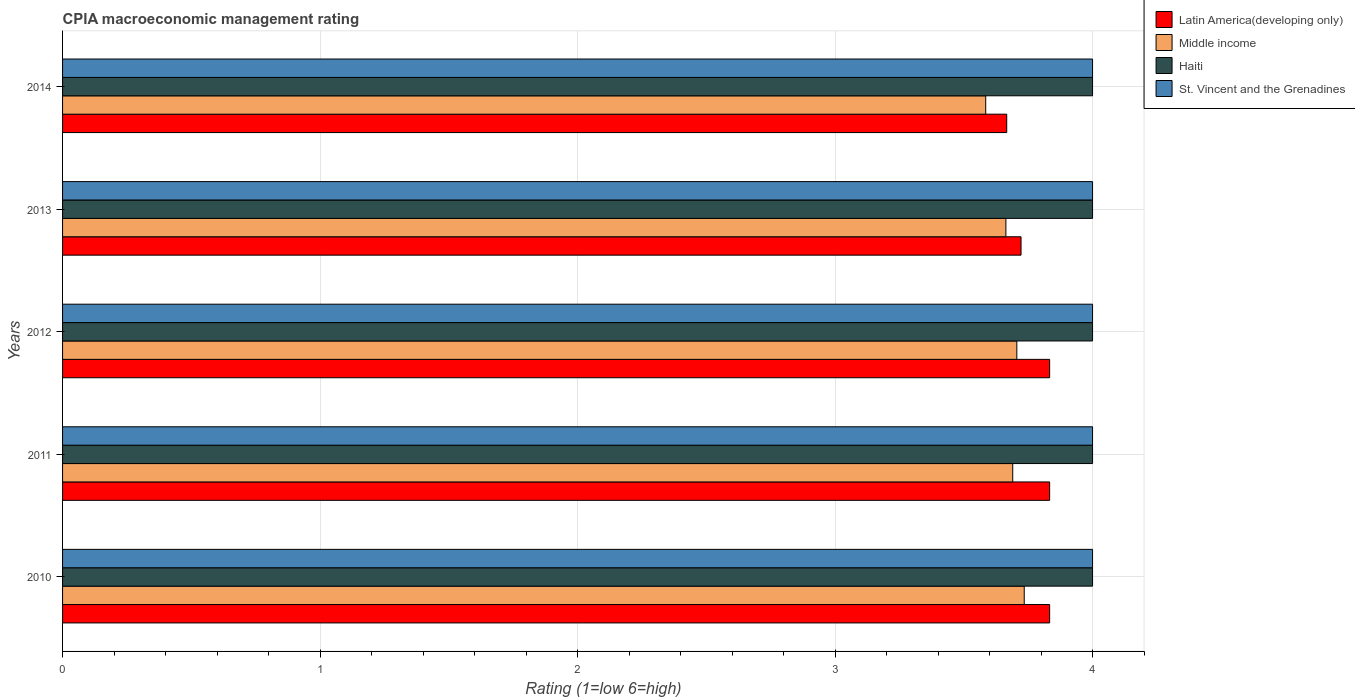How many bars are there on the 3rd tick from the top?
Provide a short and direct response. 4. What is the CPIA rating in Haiti in 2012?
Ensure brevity in your answer.  4. Across all years, what is the maximum CPIA rating in Latin America(developing only)?
Your response must be concise. 3.83. Across all years, what is the minimum CPIA rating in St. Vincent and the Grenadines?
Provide a succinct answer. 4. In which year was the CPIA rating in Latin America(developing only) maximum?
Your answer should be compact. 2010. In which year was the CPIA rating in Haiti minimum?
Offer a terse response. 2010. What is the total CPIA rating in Latin America(developing only) in the graph?
Ensure brevity in your answer.  18.89. What is the difference between the CPIA rating in Latin America(developing only) in 2011 and that in 2013?
Ensure brevity in your answer.  0.11. What is the difference between the CPIA rating in St. Vincent and the Grenadines in 2013 and the CPIA rating in Middle income in 2012?
Offer a very short reply. 0.29. What is the average CPIA rating in Middle income per year?
Ensure brevity in your answer.  3.68. In the year 2010, what is the difference between the CPIA rating in St. Vincent and the Grenadines and CPIA rating in Latin America(developing only)?
Give a very brief answer. 0.17. What is the ratio of the CPIA rating in Middle income in 2012 to that in 2014?
Provide a succinct answer. 1.03. Is the CPIA rating in Latin America(developing only) in 2012 less than that in 2014?
Your answer should be very brief. No. Is the difference between the CPIA rating in St. Vincent and the Grenadines in 2010 and 2014 greater than the difference between the CPIA rating in Latin America(developing only) in 2010 and 2014?
Your answer should be very brief. No. What is the difference between the highest and the second highest CPIA rating in St. Vincent and the Grenadines?
Make the answer very short. 0. In how many years, is the CPIA rating in Middle income greater than the average CPIA rating in Middle income taken over all years?
Provide a succinct answer. 3. Is it the case that in every year, the sum of the CPIA rating in Middle income and CPIA rating in St. Vincent and the Grenadines is greater than the sum of CPIA rating in Latin America(developing only) and CPIA rating in Haiti?
Your answer should be very brief. Yes. What does the 1st bar from the top in 2012 represents?
Give a very brief answer. St. Vincent and the Grenadines. What does the 1st bar from the bottom in 2011 represents?
Keep it short and to the point. Latin America(developing only). What is the difference between two consecutive major ticks on the X-axis?
Your response must be concise. 1. Are the values on the major ticks of X-axis written in scientific E-notation?
Offer a very short reply. No. How many legend labels are there?
Offer a terse response. 4. What is the title of the graph?
Your answer should be compact. CPIA macroeconomic management rating. Does "Malawi" appear as one of the legend labels in the graph?
Offer a terse response. No. What is the label or title of the X-axis?
Offer a terse response. Rating (1=low 6=high). What is the Rating (1=low 6=high) of Latin America(developing only) in 2010?
Your response must be concise. 3.83. What is the Rating (1=low 6=high) in Middle income in 2010?
Ensure brevity in your answer.  3.73. What is the Rating (1=low 6=high) in Haiti in 2010?
Provide a short and direct response. 4. What is the Rating (1=low 6=high) of Latin America(developing only) in 2011?
Offer a terse response. 3.83. What is the Rating (1=low 6=high) in Middle income in 2011?
Your answer should be compact. 3.69. What is the Rating (1=low 6=high) of Haiti in 2011?
Keep it short and to the point. 4. What is the Rating (1=low 6=high) in Latin America(developing only) in 2012?
Give a very brief answer. 3.83. What is the Rating (1=low 6=high) of Middle income in 2012?
Keep it short and to the point. 3.71. What is the Rating (1=low 6=high) of Haiti in 2012?
Keep it short and to the point. 4. What is the Rating (1=low 6=high) of Latin America(developing only) in 2013?
Provide a short and direct response. 3.72. What is the Rating (1=low 6=high) in Middle income in 2013?
Keep it short and to the point. 3.66. What is the Rating (1=low 6=high) of St. Vincent and the Grenadines in 2013?
Provide a succinct answer. 4. What is the Rating (1=low 6=high) of Latin America(developing only) in 2014?
Give a very brief answer. 3.67. What is the Rating (1=low 6=high) of Middle income in 2014?
Your response must be concise. 3.59. What is the Rating (1=low 6=high) of Haiti in 2014?
Your answer should be compact. 4. What is the Rating (1=low 6=high) of St. Vincent and the Grenadines in 2014?
Offer a terse response. 4. Across all years, what is the maximum Rating (1=low 6=high) in Latin America(developing only)?
Provide a short and direct response. 3.83. Across all years, what is the maximum Rating (1=low 6=high) in Middle income?
Provide a succinct answer. 3.73. Across all years, what is the maximum Rating (1=low 6=high) in Haiti?
Give a very brief answer. 4. Across all years, what is the maximum Rating (1=low 6=high) of St. Vincent and the Grenadines?
Your response must be concise. 4. Across all years, what is the minimum Rating (1=low 6=high) of Latin America(developing only)?
Make the answer very short. 3.67. Across all years, what is the minimum Rating (1=low 6=high) in Middle income?
Make the answer very short. 3.59. Across all years, what is the minimum Rating (1=low 6=high) in St. Vincent and the Grenadines?
Ensure brevity in your answer.  4. What is the total Rating (1=low 6=high) of Latin America(developing only) in the graph?
Give a very brief answer. 18.89. What is the total Rating (1=low 6=high) of Middle income in the graph?
Your answer should be compact. 18.38. What is the total Rating (1=low 6=high) of Haiti in the graph?
Your response must be concise. 20. What is the total Rating (1=low 6=high) in St. Vincent and the Grenadines in the graph?
Offer a very short reply. 20. What is the difference between the Rating (1=low 6=high) of Latin America(developing only) in 2010 and that in 2011?
Provide a succinct answer. 0. What is the difference between the Rating (1=low 6=high) of Middle income in 2010 and that in 2011?
Offer a terse response. 0.04. What is the difference between the Rating (1=low 6=high) of Haiti in 2010 and that in 2011?
Your answer should be compact. 0. What is the difference between the Rating (1=low 6=high) of St. Vincent and the Grenadines in 2010 and that in 2011?
Offer a terse response. 0. What is the difference between the Rating (1=low 6=high) of Latin America(developing only) in 2010 and that in 2012?
Offer a terse response. 0. What is the difference between the Rating (1=low 6=high) of Middle income in 2010 and that in 2012?
Provide a short and direct response. 0.03. What is the difference between the Rating (1=low 6=high) of St. Vincent and the Grenadines in 2010 and that in 2012?
Provide a succinct answer. 0. What is the difference between the Rating (1=low 6=high) in Latin America(developing only) in 2010 and that in 2013?
Offer a very short reply. 0.11. What is the difference between the Rating (1=low 6=high) in Middle income in 2010 and that in 2013?
Offer a terse response. 0.07. What is the difference between the Rating (1=low 6=high) of Middle income in 2010 and that in 2014?
Give a very brief answer. 0.15. What is the difference between the Rating (1=low 6=high) in Latin America(developing only) in 2011 and that in 2012?
Your answer should be very brief. 0. What is the difference between the Rating (1=low 6=high) of Middle income in 2011 and that in 2012?
Keep it short and to the point. -0.02. What is the difference between the Rating (1=low 6=high) of St. Vincent and the Grenadines in 2011 and that in 2012?
Ensure brevity in your answer.  0. What is the difference between the Rating (1=low 6=high) in Middle income in 2011 and that in 2013?
Offer a terse response. 0.03. What is the difference between the Rating (1=low 6=high) of Haiti in 2011 and that in 2013?
Your response must be concise. 0. What is the difference between the Rating (1=low 6=high) in Latin America(developing only) in 2011 and that in 2014?
Provide a short and direct response. 0.17. What is the difference between the Rating (1=low 6=high) in Middle income in 2011 and that in 2014?
Give a very brief answer. 0.1. What is the difference between the Rating (1=low 6=high) of Middle income in 2012 and that in 2013?
Provide a succinct answer. 0.04. What is the difference between the Rating (1=low 6=high) in St. Vincent and the Grenadines in 2012 and that in 2013?
Your answer should be compact. 0. What is the difference between the Rating (1=low 6=high) of Latin America(developing only) in 2012 and that in 2014?
Offer a very short reply. 0.17. What is the difference between the Rating (1=low 6=high) in Middle income in 2012 and that in 2014?
Make the answer very short. 0.12. What is the difference between the Rating (1=low 6=high) of Haiti in 2012 and that in 2014?
Your response must be concise. 0. What is the difference between the Rating (1=low 6=high) of Latin America(developing only) in 2013 and that in 2014?
Ensure brevity in your answer.  0.06. What is the difference between the Rating (1=low 6=high) in Middle income in 2013 and that in 2014?
Ensure brevity in your answer.  0.08. What is the difference between the Rating (1=low 6=high) of Haiti in 2013 and that in 2014?
Ensure brevity in your answer.  0. What is the difference between the Rating (1=low 6=high) of Latin America(developing only) in 2010 and the Rating (1=low 6=high) of Middle income in 2011?
Provide a succinct answer. 0.14. What is the difference between the Rating (1=low 6=high) in Middle income in 2010 and the Rating (1=low 6=high) in Haiti in 2011?
Ensure brevity in your answer.  -0.27. What is the difference between the Rating (1=low 6=high) of Middle income in 2010 and the Rating (1=low 6=high) of St. Vincent and the Grenadines in 2011?
Your answer should be compact. -0.27. What is the difference between the Rating (1=low 6=high) of Latin America(developing only) in 2010 and the Rating (1=low 6=high) of Middle income in 2012?
Your answer should be compact. 0.13. What is the difference between the Rating (1=low 6=high) of Latin America(developing only) in 2010 and the Rating (1=low 6=high) of Haiti in 2012?
Your answer should be very brief. -0.17. What is the difference between the Rating (1=low 6=high) in Latin America(developing only) in 2010 and the Rating (1=low 6=high) in St. Vincent and the Grenadines in 2012?
Your answer should be very brief. -0.17. What is the difference between the Rating (1=low 6=high) of Middle income in 2010 and the Rating (1=low 6=high) of Haiti in 2012?
Offer a terse response. -0.27. What is the difference between the Rating (1=low 6=high) in Middle income in 2010 and the Rating (1=low 6=high) in St. Vincent and the Grenadines in 2012?
Offer a terse response. -0.27. What is the difference between the Rating (1=low 6=high) in Haiti in 2010 and the Rating (1=low 6=high) in St. Vincent and the Grenadines in 2012?
Ensure brevity in your answer.  0. What is the difference between the Rating (1=low 6=high) of Latin America(developing only) in 2010 and the Rating (1=low 6=high) of Middle income in 2013?
Keep it short and to the point. 0.17. What is the difference between the Rating (1=low 6=high) in Latin America(developing only) in 2010 and the Rating (1=low 6=high) in Haiti in 2013?
Give a very brief answer. -0.17. What is the difference between the Rating (1=low 6=high) in Middle income in 2010 and the Rating (1=low 6=high) in Haiti in 2013?
Ensure brevity in your answer.  -0.27. What is the difference between the Rating (1=low 6=high) in Middle income in 2010 and the Rating (1=low 6=high) in St. Vincent and the Grenadines in 2013?
Your answer should be compact. -0.27. What is the difference between the Rating (1=low 6=high) in Latin America(developing only) in 2010 and the Rating (1=low 6=high) in Middle income in 2014?
Make the answer very short. 0.25. What is the difference between the Rating (1=low 6=high) in Latin America(developing only) in 2010 and the Rating (1=low 6=high) in Haiti in 2014?
Your answer should be very brief. -0.17. What is the difference between the Rating (1=low 6=high) of Latin America(developing only) in 2010 and the Rating (1=low 6=high) of St. Vincent and the Grenadines in 2014?
Offer a terse response. -0.17. What is the difference between the Rating (1=low 6=high) of Middle income in 2010 and the Rating (1=low 6=high) of Haiti in 2014?
Offer a very short reply. -0.27. What is the difference between the Rating (1=low 6=high) in Middle income in 2010 and the Rating (1=low 6=high) in St. Vincent and the Grenadines in 2014?
Offer a very short reply. -0.27. What is the difference between the Rating (1=low 6=high) in Haiti in 2010 and the Rating (1=low 6=high) in St. Vincent and the Grenadines in 2014?
Offer a very short reply. 0. What is the difference between the Rating (1=low 6=high) in Latin America(developing only) in 2011 and the Rating (1=low 6=high) in Middle income in 2012?
Make the answer very short. 0.13. What is the difference between the Rating (1=low 6=high) in Latin America(developing only) in 2011 and the Rating (1=low 6=high) in Haiti in 2012?
Your response must be concise. -0.17. What is the difference between the Rating (1=low 6=high) of Latin America(developing only) in 2011 and the Rating (1=low 6=high) of St. Vincent and the Grenadines in 2012?
Your answer should be compact. -0.17. What is the difference between the Rating (1=low 6=high) of Middle income in 2011 and the Rating (1=low 6=high) of Haiti in 2012?
Provide a short and direct response. -0.31. What is the difference between the Rating (1=low 6=high) in Middle income in 2011 and the Rating (1=low 6=high) in St. Vincent and the Grenadines in 2012?
Your answer should be compact. -0.31. What is the difference between the Rating (1=low 6=high) in Haiti in 2011 and the Rating (1=low 6=high) in St. Vincent and the Grenadines in 2012?
Your answer should be compact. 0. What is the difference between the Rating (1=low 6=high) in Latin America(developing only) in 2011 and the Rating (1=low 6=high) in Middle income in 2013?
Make the answer very short. 0.17. What is the difference between the Rating (1=low 6=high) in Middle income in 2011 and the Rating (1=low 6=high) in Haiti in 2013?
Your response must be concise. -0.31. What is the difference between the Rating (1=low 6=high) in Middle income in 2011 and the Rating (1=low 6=high) in St. Vincent and the Grenadines in 2013?
Give a very brief answer. -0.31. What is the difference between the Rating (1=low 6=high) in Latin America(developing only) in 2011 and the Rating (1=low 6=high) in Middle income in 2014?
Provide a succinct answer. 0.25. What is the difference between the Rating (1=low 6=high) of Latin America(developing only) in 2011 and the Rating (1=low 6=high) of Haiti in 2014?
Offer a terse response. -0.17. What is the difference between the Rating (1=low 6=high) of Middle income in 2011 and the Rating (1=low 6=high) of Haiti in 2014?
Provide a short and direct response. -0.31. What is the difference between the Rating (1=low 6=high) in Middle income in 2011 and the Rating (1=low 6=high) in St. Vincent and the Grenadines in 2014?
Offer a very short reply. -0.31. What is the difference between the Rating (1=low 6=high) of Latin America(developing only) in 2012 and the Rating (1=low 6=high) of Middle income in 2013?
Your answer should be very brief. 0.17. What is the difference between the Rating (1=low 6=high) in Latin America(developing only) in 2012 and the Rating (1=low 6=high) in Haiti in 2013?
Your answer should be very brief. -0.17. What is the difference between the Rating (1=low 6=high) in Latin America(developing only) in 2012 and the Rating (1=low 6=high) in St. Vincent and the Grenadines in 2013?
Make the answer very short. -0.17. What is the difference between the Rating (1=low 6=high) of Middle income in 2012 and the Rating (1=low 6=high) of Haiti in 2013?
Keep it short and to the point. -0.29. What is the difference between the Rating (1=low 6=high) of Middle income in 2012 and the Rating (1=low 6=high) of St. Vincent and the Grenadines in 2013?
Your answer should be very brief. -0.29. What is the difference between the Rating (1=low 6=high) in Latin America(developing only) in 2012 and the Rating (1=low 6=high) in Middle income in 2014?
Keep it short and to the point. 0.25. What is the difference between the Rating (1=low 6=high) in Latin America(developing only) in 2012 and the Rating (1=low 6=high) in Haiti in 2014?
Your answer should be compact. -0.17. What is the difference between the Rating (1=low 6=high) in Middle income in 2012 and the Rating (1=low 6=high) in Haiti in 2014?
Provide a short and direct response. -0.29. What is the difference between the Rating (1=low 6=high) in Middle income in 2012 and the Rating (1=low 6=high) in St. Vincent and the Grenadines in 2014?
Keep it short and to the point. -0.29. What is the difference between the Rating (1=low 6=high) in Latin America(developing only) in 2013 and the Rating (1=low 6=high) in Middle income in 2014?
Make the answer very short. 0.14. What is the difference between the Rating (1=low 6=high) in Latin America(developing only) in 2013 and the Rating (1=low 6=high) in Haiti in 2014?
Give a very brief answer. -0.28. What is the difference between the Rating (1=low 6=high) of Latin America(developing only) in 2013 and the Rating (1=low 6=high) of St. Vincent and the Grenadines in 2014?
Ensure brevity in your answer.  -0.28. What is the difference between the Rating (1=low 6=high) in Middle income in 2013 and the Rating (1=low 6=high) in Haiti in 2014?
Your response must be concise. -0.34. What is the difference between the Rating (1=low 6=high) in Middle income in 2013 and the Rating (1=low 6=high) in St. Vincent and the Grenadines in 2014?
Your answer should be compact. -0.34. What is the difference between the Rating (1=low 6=high) of Haiti in 2013 and the Rating (1=low 6=high) of St. Vincent and the Grenadines in 2014?
Your response must be concise. 0. What is the average Rating (1=low 6=high) in Latin America(developing only) per year?
Offer a terse response. 3.78. What is the average Rating (1=low 6=high) of Middle income per year?
Your response must be concise. 3.68. What is the average Rating (1=low 6=high) of Haiti per year?
Make the answer very short. 4. What is the average Rating (1=low 6=high) in St. Vincent and the Grenadines per year?
Your answer should be compact. 4. In the year 2010, what is the difference between the Rating (1=low 6=high) of Latin America(developing only) and Rating (1=low 6=high) of Middle income?
Your response must be concise. 0.1. In the year 2010, what is the difference between the Rating (1=low 6=high) of Latin America(developing only) and Rating (1=low 6=high) of St. Vincent and the Grenadines?
Your answer should be very brief. -0.17. In the year 2010, what is the difference between the Rating (1=low 6=high) in Middle income and Rating (1=low 6=high) in Haiti?
Ensure brevity in your answer.  -0.27. In the year 2010, what is the difference between the Rating (1=low 6=high) of Middle income and Rating (1=low 6=high) of St. Vincent and the Grenadines?
Give a very brief answer. -0.27. In the year 2011, what is the difference between the Rating (1=low 6=high) of Latin America(developing only) and Rating (1=low 6=high) of Middle income?
Provide a short and direct response. 0.14. In the year 2011, what is the difference between the Rating (1=low 6=high) of Middle income and Rating (1=low 6=high) of Haiti?
Ensure brevity in your answer.  -0.31. In the year 2011, what is the difference between the Rating (1=low 6=high) of Middle income and Rating (1=low 6=high) of St. Vincent and the Grenadines?
Provide a short and direct response. -0.31. In the year 2011, what is the difference between the Rating (1=low 6=high) of Haiti and Rating (1=low 6=high) of St. Vincent and the Grenadines?
Keep it short and to the point. 0. In the year 2012, what is the difference between the Rating (1=low 6=high) in Latin America(developing only) and Rating (1=low 6=high) in Middle income?
Your answer should be compact. 0.13. In the year 2012, what is the difference between the Rating (1=low 6=high) in Latin America(developing only) and Rating (1=low 6=high) in St. Vincent and the Grenadines?
Your answer should be very brief. -0.17. In the year 2012, what is the difference between the Rating (1=low 6=high) of Middle income and Rating (1=low 6=high) of Haiti?
Ensure brevity in your answer.  -0.29. In the year 2012, what is the difference between the Rating (1=low 6=high) of Middle income and Rating (1=low 6=high) of St. Vincent and the Grenadines?
Offer a very short reply. -0.29. In the year 2012, what is the difference between the Rating (1=low 6=high) in Haiti and Rating (1=low 6=high) in St. Vincent and the Grenadines?
Offer a very short reply. 0. In the year 2013, what is the difference between the Rating (1=low 6=high) in Latin America(developing only) and Rating (1=low 6=high) in Middle income?
Offer a terse response. 0.06. In the year 2013, what is the difference between the Rating (1=low 6=high) of Latin America(developing only) and Rating (1=low 6=high) of Haiti?
Offer a very short reply. -0.28. In the year 2013, what is the difference between the Rating (1=low 6=high) in Latin America(developing only) and Rating (1=low 6=high) in St. Vincent and the Grenadines?
Give a very brief answer. -0.28. In the year 2013, what is the difference between the Rating (1=low 6=high) in Middle income and Rating (1=low 6=high) in Haiti?
Give a very brief answer. -0.34. In the year 2013, what is the difference between the Rating (1=low 6=high) in Middle income and Rating (1=low 6=high) in St. Vincent and the Grenadines?
Provide a short and direct response. -0.34. In the year 2013, what is the difference between the Rating (1=low 6=high) of Haiti and Rating (1=low 6=high) of St. Vincent and the Grenadines?
Your answer should be compact. 0. In the year 2014, what is the difference between the Rating (1=low 6=high) in Latin America(developing only) and Rating (1=low 6=high) in Middle income?
Provide a succinct answer. 0.08. In the year 2014, what is the difference between the Rating (1=low 6=high) in Latin America(developing only) and Rating (1=low 6=high) in Haiti?
Provide a short and direct response. -0.33. In the year 2014, what is the difference between the Rating (1=low 6=high) in Middle income and Rating (1=low 6=high) in Haiti?
Offer a terse response. -0.41. In the year 2014, what is the difference between the Rating (1=low 6=high) of Middle income and Rating (1=low 6=high) of St. Vincent and the Grenadines?
Provide a succinct answer. -0.41. In the year 2014, what is the difference between the Rating (1=low 6=high) of Haiti and Rating (1=low 6=high) of St. Vincent and the Grenadines?
Provide a succinct answer. 0. What is the ratio of the Rating (1=low 6=high) in Latin America(developing only) in 2010 to that in 2011?
Give a very brief answer. 1. What is the ratio of the Rating (1=low 6=high) of Middle income in 2010 to that in 2011?
Offer a very short reply. 1.01. What is the ratio of the Rating (1=low 6=high) in Latin America(developing only) in 2010 to that in 2012?
Your answer should be very brief. 1. What is the ratio of the Rating (1=low 6=high) of Latin America(developing only) in 2010 to that in 2013?
Make the answer very short. 1.03. What is the ratio of the Rating (1=low 6=high) of Middle income in 2010 to that in 2013?
Keep it short and to the point. 1.02. What is the ratio of the Rating (1=low 6=high) in Latin America(developing only) in 2010 to that in 2014?
Provide a short and direct response. 1.05. What is the ratio of the Rating (1=low 6=high) of Middle income in 2010 to that in 2014?
Offer a terse response. 1.04. What is the ratio of the Rating (1=low 6=high) of Haiti in 2010 to that in 2014?
Give a very brief answer. 1. What is the ratio of the Rating (1=low 6=high) in St. Vincent and the Grenadines in 2010 to that in 2014?
Offer a terse response. 1. What is the ratio of the Rating (1=low 6=high) of Latin America(developing only) in 2011 to that in 2013?
Your answer should be very brief. 1.03. What is the ratio of the Rating (1=low 6=high) of Latin America(developing only) in 2011 to that in 2014?
Provide a succinct answer. 1.05. What is the ratio of the Rating (1=low 6=high) in Middle income in 2011 to that in 2014?
Make the answer very short. 1.03. What is the ratio of the Rating (1=low 6=high) of St. Vincent and the Grenadines in 2011 to that in 2014?
Offer a very short reply. 1. What is the ratio of the Rating (1=low 6=high) of Latin America(developing only) in 2012 to that in 2013?
Your answer should be very brief. 1.03. What is the ratio of the Rating (1=low 6=high) in Middle income in 2012 to that in 2013?
Provide a short and direct response. 1.01. What is the ratio of the Rating (1=low 6=high) in Haiti in 2012 to that in 2013?
Keep it short and to the point. 1. What is the ratio of the Rating (1=low 6=high) in Latin America(developing only) in 2012 to that in 2014?
Offer a terse response. 1.05. What is the ratio of the Rating (1=low 6=high) in Middle income in 2012 to that in 2014?
Your answer should be very brief. 1.03. What is the ratio of the Rating (1=low 6=high) of St. Vincent and the Grenadines in 2012 to that in 2014?
Your answer should be very brief. 1. What is the ratio of the Rating (1=low 6=high) in Latin America(developing only) in 2013 to that in 2014?
Your answer should be compact. 1.02. What is the ratio of the Rating (1=low 6=high) in Middle income in 2013 to that in 2014?
Provide a succinct answer. 1.02. What is the ratio of the Rating (1=low 6=high) of St. Vincent and the Grenadines in 2013 to that in 2014?
Give a very brief answer. 1. What is the difference between the highest and the second highest Rating (1=low 6=high) in Latin America(developing only)?
Offer a very short reply. 0. What is the difference between the highest and the second highest Rating (1=low 6=high) of Middle income?
Keep it short and to the point. 0.03. What is the difference between the highest and the second highest Rating (1=low 6=high) in St. Vincent and the Grenadines?
Provide a succinct answer. 0. What is the difference between the highest and the lowest Rating (1=low 6=high) of Latin America(developing only)?
Offer a terse response. 0.17. What is the difference between the highest and the lowest Rating (1=low 6=high) of Middle income?
Provide a succinct answer. 0.15. 